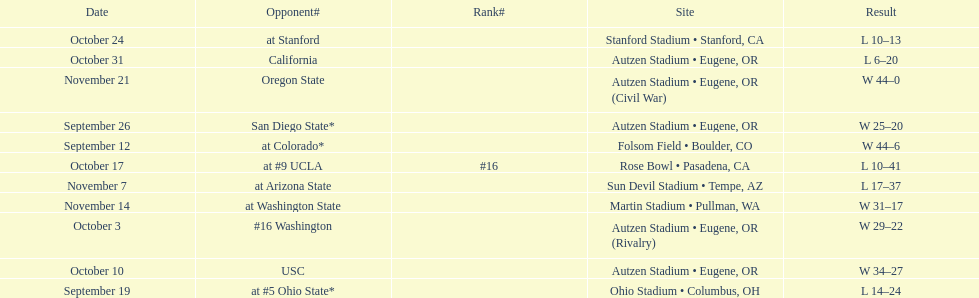Did the team win or lose more games? Win. 